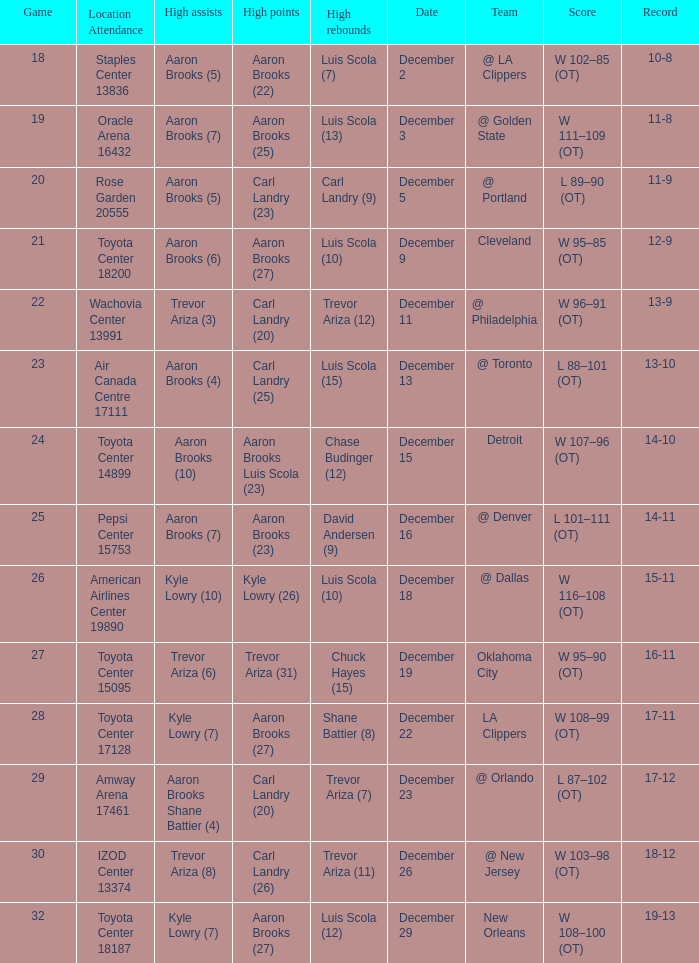Where was the game in which Carl Landry (25) did the most high points played? Air Canada Centre 17111. 